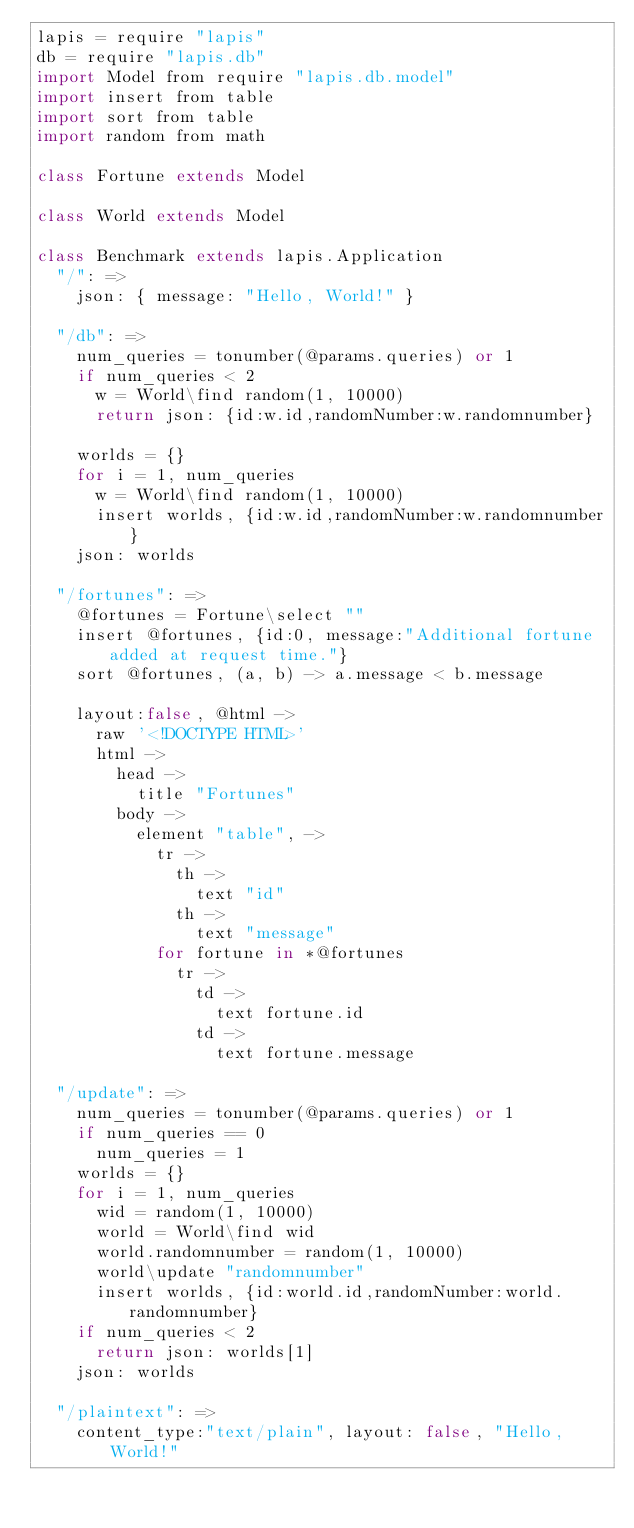Convert code to text. <code><loc_0><loc_0><loc_500><loc_500><_MoonScript_>lapis = require "lapis"
db = require "lapis.db"
import Model from require "lapis.db.model"
import insert from table
import sort from table
import random from math

class Fortune extends Model

class World extends Model

class Benchmark extends lapis.Application
  "/": =>
    json: { message: "Hello, World!" }

  "/db": =>
    num_queries = tonumber(@params.queries) or 1
    if num_queries < 2 
      w = World\find random(1, 10000)
      return json: {id:w.id,randomNumber:w.randomnumber}

    worlds = {}
    for i = 1, num_queries
      w = World\find random(1, 10000)
      insert worlds, {id:w.id,randomNumber:w.randomnumber} 
    json: worlds

  "/fortunes": =>
    @fortunes = Fortune\select ""
    insert @fortunes, {id:0, message:"Additional fortune added at request time."}
    sort @fortunes, (a, b) -> a.message < b.message

    layout:false, @html ->
      raw '<!DOCTYPE HTML>'
      html ->
        head ->
          title "Fortunes"
        body ->
          element "table", ->
            tr ->
              th ->
                text "id"
              th ->
                text "message"
            for fortune in *@fortunes
              tr ->
                td ->
                  text fortune.id
                td ->
                  text fortune.message

  "/update": =>
    num_queries = tonumber(@params.queries) or 1
    if num_queries == 0
      num_queries = 1
    worlds = {}
    for i = 1, num_queries
      wid = random(1, 10000)
      world = World\find wid
      world.randomnumber = random(1, 10000)
      world\update "randomnumber"
      insert worlds, {id:world.id,randomNumber:world.randomnumber} 
    if num_queries < 2
      return json: worlds[1]
    json: worlds

  "/plaintext": =>
    content_type:"text/plain", layout: false, "Hello, World!"
              
</code> 